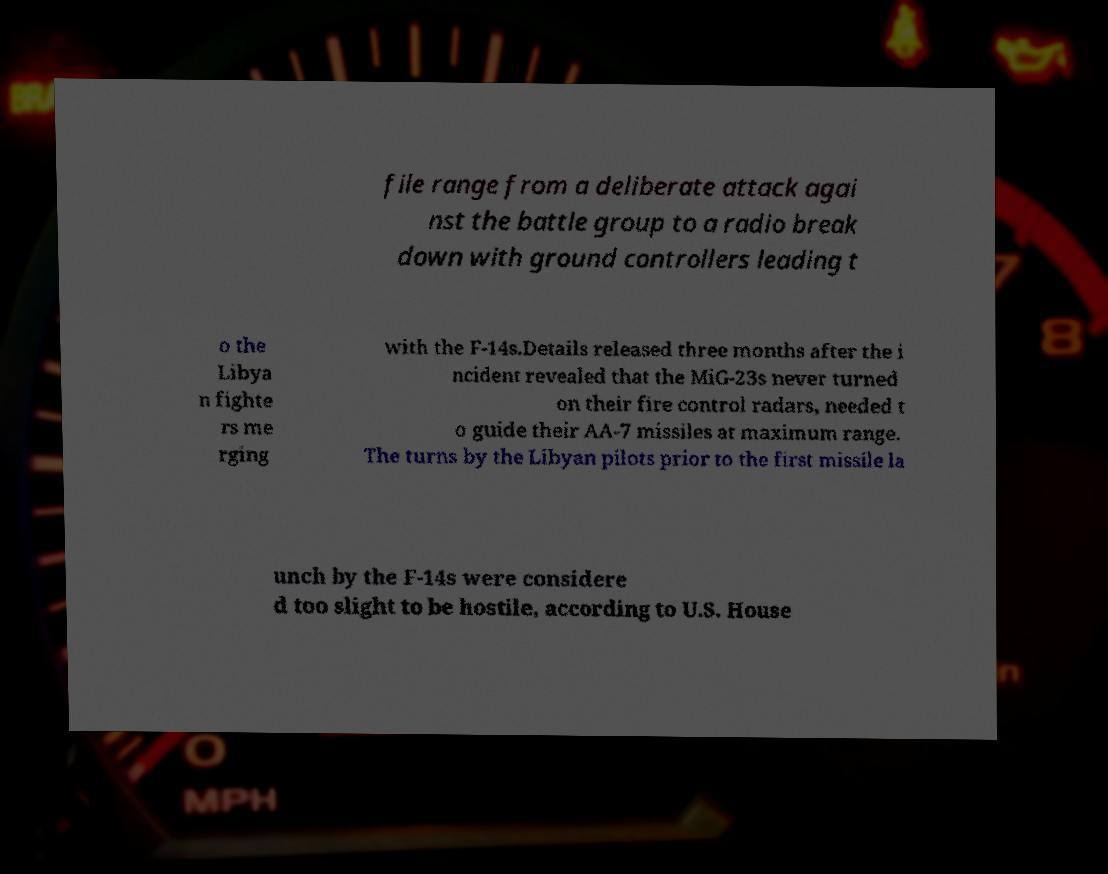Could you assist in decoding the text presented in this image and type it out clearly? file range from a deliberate attack agai nst the battle group to a radio break down with ground controllers leading t o the Libya n fighte rs me rging with the F-14s.Details released three months after the i ncident revealed that the MiG-23s never turned on their fire control radars, needed t o guide their AA-7 missiles at maximum range. The turns by the Libyan pilots prior to the first missile la unch by the F-14s were considere d too slight to be hostile, according to U.S. House 